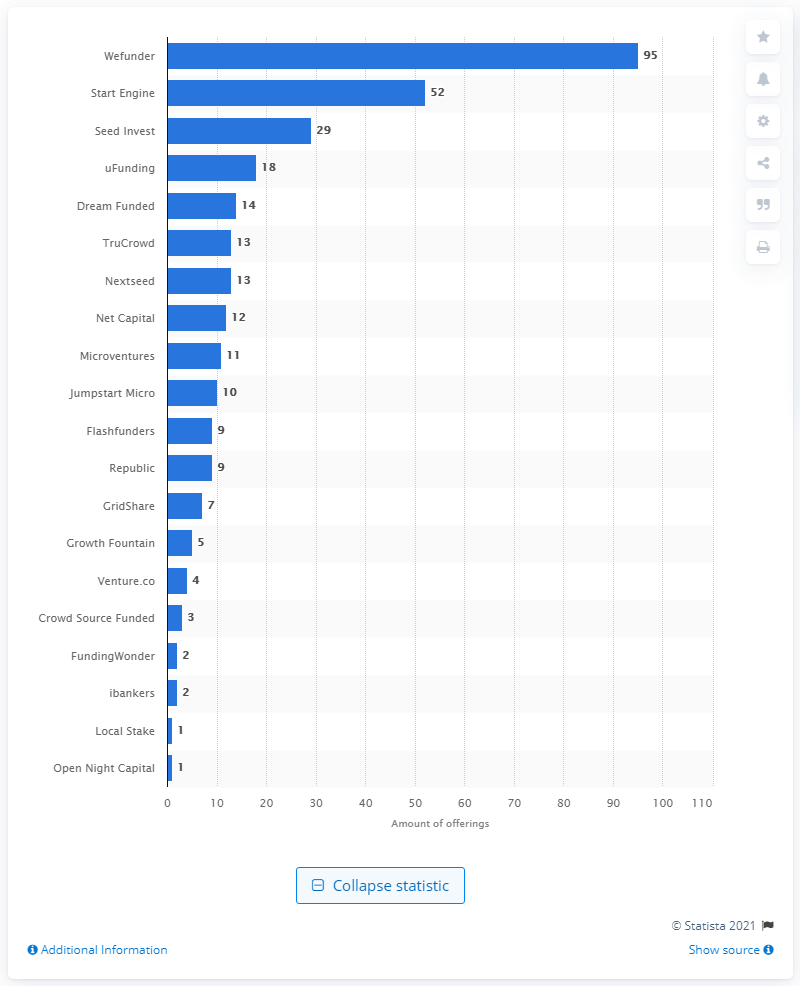Give some essential details in this illustration. As of May 2017, Wefunder had 95 offerings. 